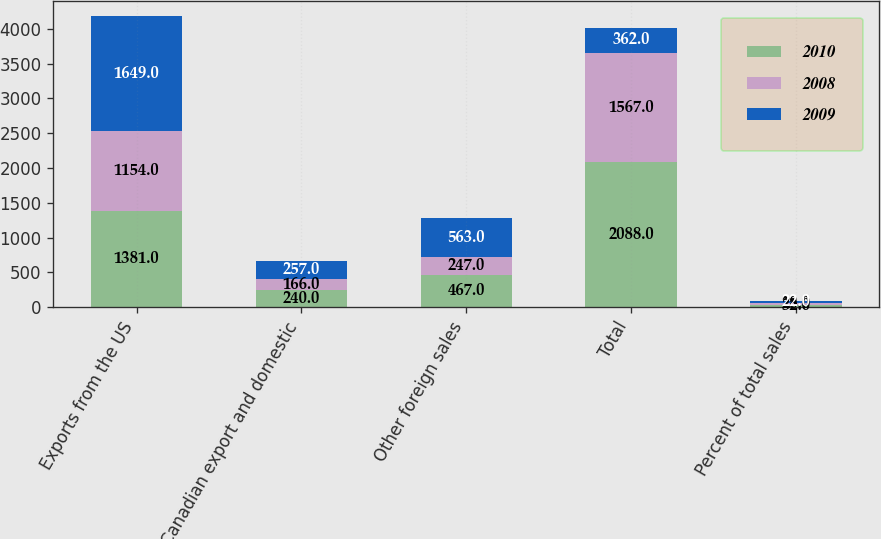Convert chart. <chart><loc_0><loc_0><loc_500><loc_500><stacked_bar_chart><ecel><fcel>Exports from the US<fcel>Canadian export and domestic<fcel>Other foreign sales<fcel>Total<fcel>Percent of total sales<nl><fcel>2010<fcel>1381<fcel>240<fcel>467<fcel>2088<fcel>32<nl><fcel>2008<fcel>1154<fcel>166<fcel>247<fcel>1567<fcel>28<nl><fcel>2009<fcel>1649<fcel>257<fcel>563<fcel>362<fcel>22<nl></chart> 